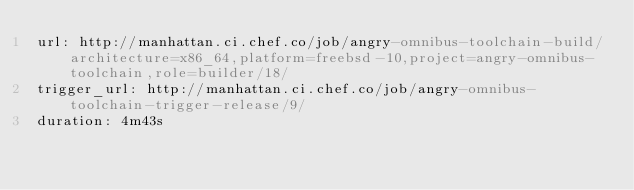Convert code to text. <code><loc_0><loc_0><loc_500><loc_500><_YAML_>url: http://manhattan.ci.chef.co/job/angry-omnibus-toolchain-build/architecture=x86_64,platform=freebsd-10,project=angry-omnibus-toolchain,role=builder/18/
trigger_url: http://manhattan.ci.chef.co/job/angry-omnibus-toolchain-trigger-release/9/
duration: 4m43s
</code> 